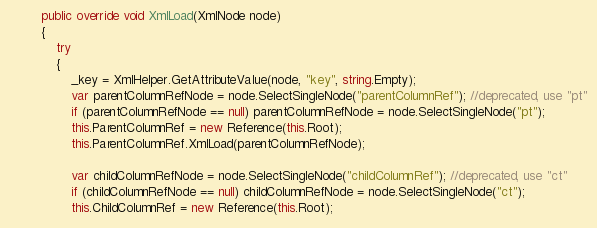Convert code to text. <code><loc_0><loc_0><loc_500><loc_500><_C#_>
		public override void XmlLoad(XmlNode node)
		{
			try
			{
				_key = XmlHelper.GetAttributeValue(node, "key", string.Empty);
				var parentColumnRefNode = node.SelectSingleNode("parentColumnRef"); //deprecated, use "pt"
				if (parentColumnRefNode == null) parentColumnRefNode = node.SelectSingleNode("pt");
				this.ParentColumnRef = new Reference(this.Root);
				this.ParentColumnRef.XmlLoad(parentColumnRefNode);

				var childColumnRefNode = node.SelectSingleNode("childColumnRef"); //deprecated, use "ct"
				if (childColumnRefNode == null) childColumnRefNode = node.SelectSingleNode("ct");
				this.ChildColumnRef = new Reference(this.Root);</code> 